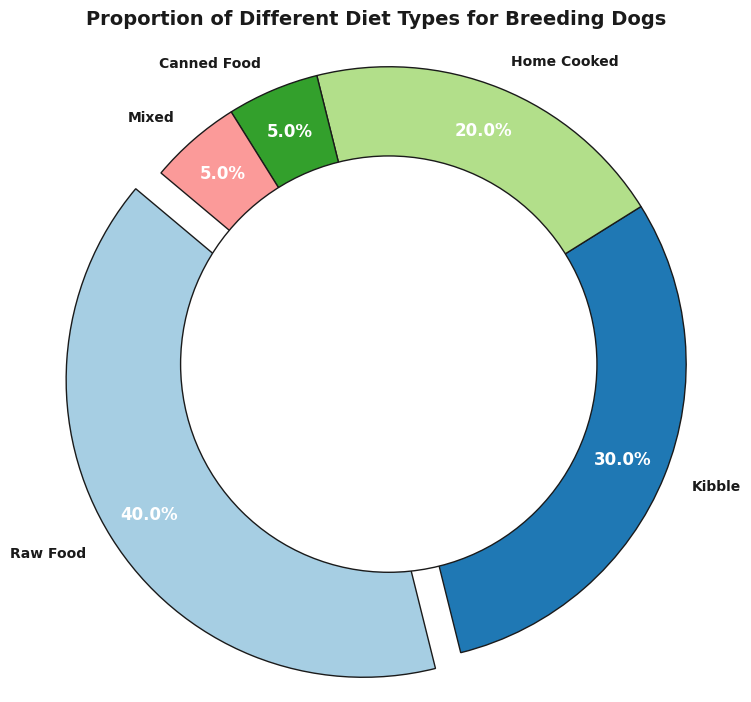What percentage of the breeding dogs are given Raw Food? Look at the Raw Food segment in the pie chart. The pie chart indicates the percentage as 40%.
Answer: 40% How much more common is Kibble compared to Canned Food? Find the percentages of Kibble and Canned Food from the pie chart, which are 30% and 5%, respectively. The difference is 30% - 5% = 25%.
Answer: 25% What is the combined proportion of dogs on Home Cooked and Mixed diets? Find the percentages for Home Cooked and Mixed diets from the pie chart, which are 20% and 5%, respectively. Adding them gives 20% + 5% = 25%.
Answer: 25% Which diet type has the smallest proportion? Look at the proportions of each diet type in the pie chart. The diet type with the smallest proportion is either Canned Food or Mixed, each at 5%.
Answer: Canned Food (or Mixed) What segment has the highest proportion, and what is the visual indicator of this? Look at the pie chart; Raw Food has the highest proportion at 40%. The segment is visually indicated with a slight separation (explode) due to its significance.
Answer: Raw Food Is the proportion of dogs fed with Mixed and Canned Food combined greater than those fed with Home Cooked? Combine the percentages of Mixed and Canned Food: 5% + 5% = 10%. Compare it to the Home Cooked proportion, which is 20%. Since 10% < 20%, it is not greater.
Answer: No What visual technique is employed to highlight the segment with the highest proportion? The segment with the highest proportion is highlighted using an 'explode' effect, which slightly separates it from the rest of the pie.
Answer: Explode effect Which color represents the Home Cooked diet on the pie chart? Locate the Home Cooked segment in the pie chart and identify its color; it's represented in the legend or the pie chart itself.
Answer: The color used as per the visual chart (exact color name might vary as per the chart settings) What is the difference between the proportion of dogs fed Raw Food and the combined proportion of dogs fed Kibble and Home Cooked? Identify the percentages from the pie chart: Raw Food is 40%, Kibble is 30%, and Home Cooked is 20%. Combine Kibble and Home Cooked: 30% + 20% = 50%. The difference: 50% - 40% = 10%.
Answer: 10% Is the proportion of dogs on Kibble closer to the proportion of dogs on Raw Food or Home Cooked? Compare the proportion of Kibble (30%) to Raw Food (40%) and Home Cooked (20%). Kibble is closer to Home Cooked because the difference is smaller:
Answer: Home Cooked 